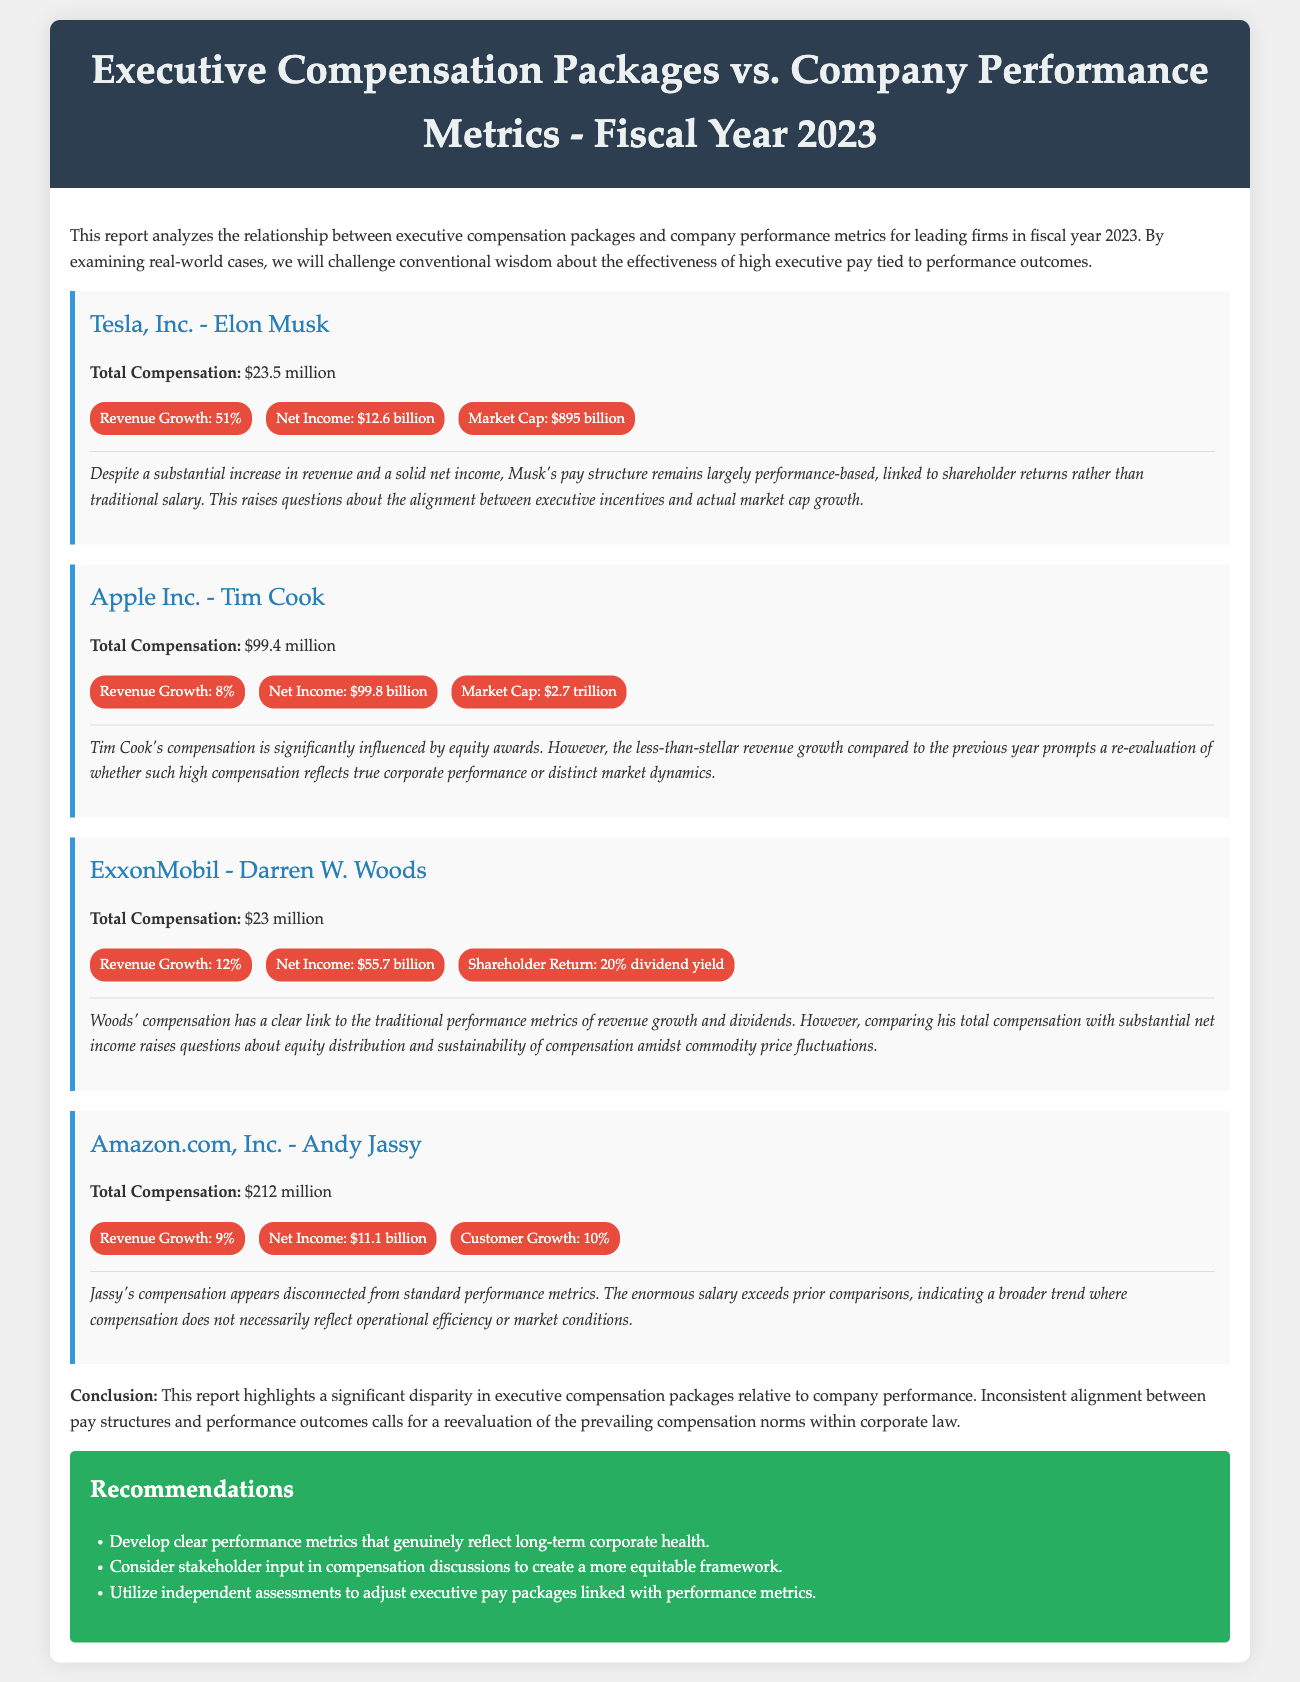What is Elon Musk's total compensation? The document states that Elon Musk's total compensation for the fiscal year is $23.5 million.
Answer: $23.5 million What was Apple Inc.'s revenue growth? Apple Inc.'s revenue growth is listed as 8% in the report.
Answer: 8% What is the market cap of Amazon.com, Inc.? The market cap of Amazon.com, Inc. is provided as $1.5 trillion.
Answer: $1.5 trillion What is the net income reported for ExxonMobil? The net income reported for ExxonMobil in the document is $55.7 billion.
Answer: $55.7 billion How does Tim Cook's compensation relate to revenue growth? Tim Cook's compensation is influenced by equity awards, which prompts reevaluation regarding high compensation reflecting true corporate performance despite lower revenue growth.
Answer: Reevaluation needed What percentage of dividend yield is reported for ExxonMobil? ExxonMobil's shareholder return includes a 20% dividend yield.
Answer: 20% What trend is indicated in Andy Jassy's compensation? Andy Jassy's compensation appears disconnected from standard performance metrics, indicating a broader trend where pay does not reflect operational efficiency or market conditions.
Answer: Disconnected trend What is one key recommendation from the report? One of the recommendations is to develop clear performance metrics that genuinely reflect long-term corporate health.
Answer: Develop clear metrics 